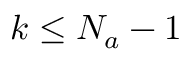Convert formula to latex. <formula><loc_0><loc_0><loc_500><loc_500>k \leq N _ { a } - 1</formula> 